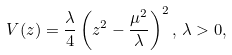Convert formula to latex. <formula><loc_0><loc_0><loc_500><loc_500>V ( z ) = \frac { \lambda } { 4 } \left ( z ^ { 2 } - \frac { \mu ^ { 2 } } { \lambda } \right ) ^ { 2 } , \, \lambda > 0 ,</formula> 